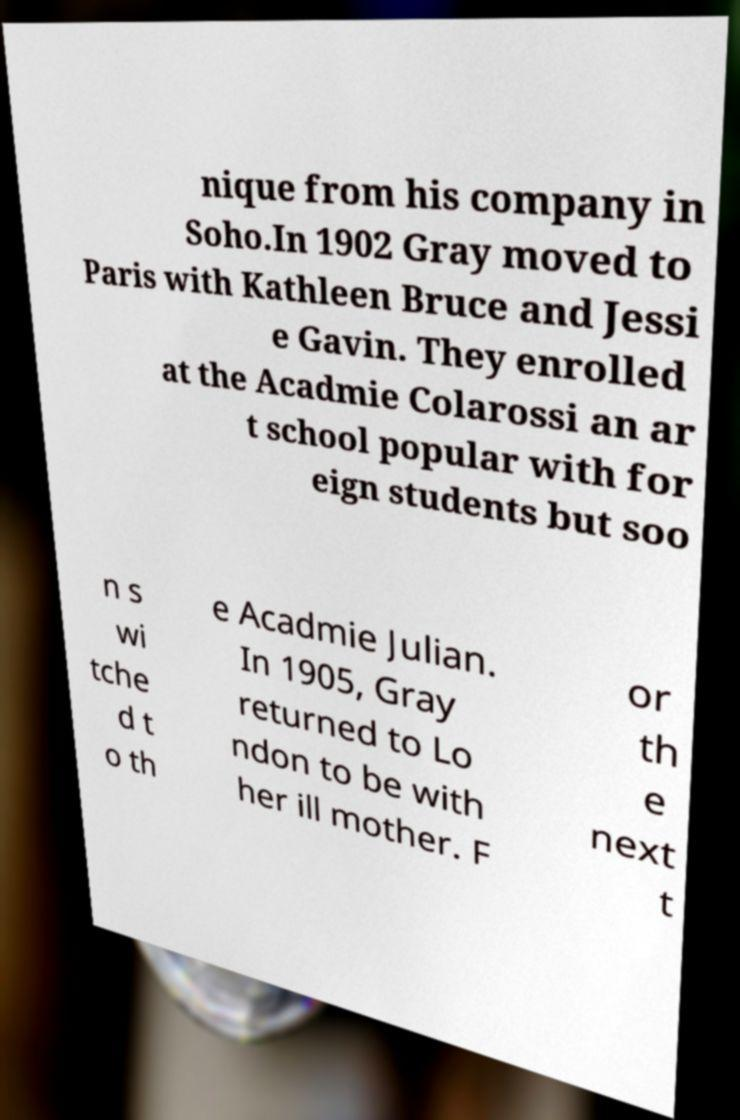Can you accurately transcribe the text from the provided image for me? nique from his company in Soho.In 1902 Gray moved to Paris with Kathleen Bruce and Jessi e Gavin. They enrolled at the Acadmie Colarossi an ar t school popular with for eign students but soo n s wi tche d t o th e Acadmie Julian. In 1905, Gray returned to Lo ndon to be with her ill mother. F or th e next t 